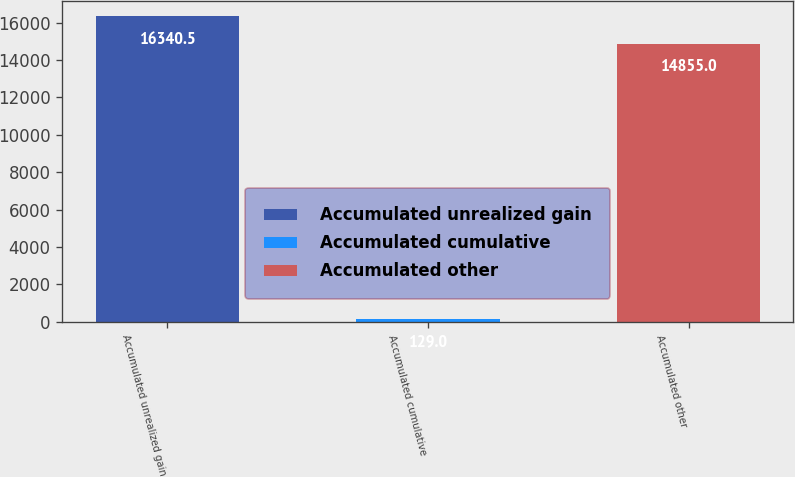Convert chart to OTSL. <chart><loc_0><loc_0><loc_500><loc_500><bar_chart><fcel>Accumulated unrealized gain<fcel>Accumulated cumulative<fcel>Accumulated other<nl><fcel>16340.5<fcel>129<fcel>14855<nl></chart> 